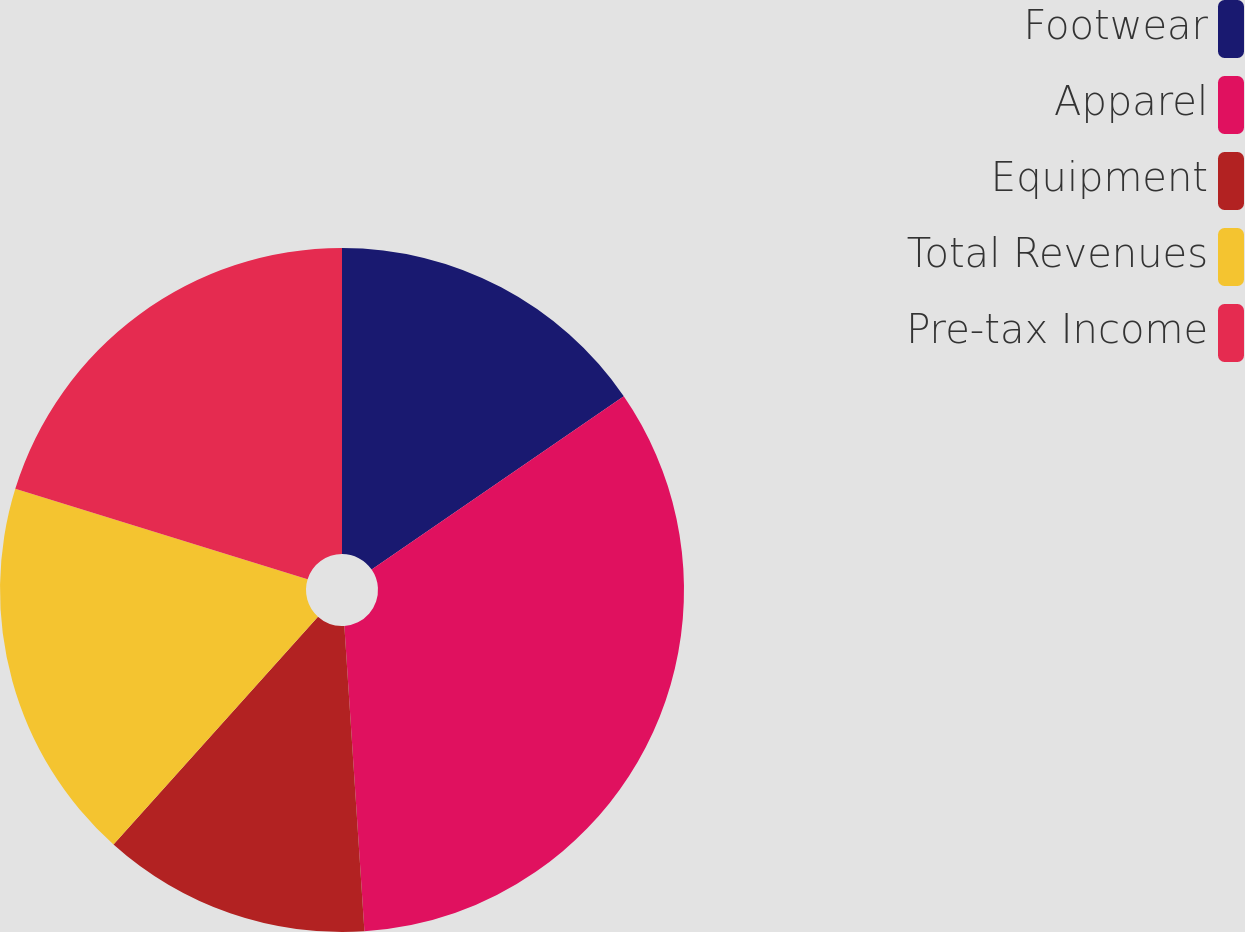Convert chart to OTSL. <chart><loc_0><loc_0><loc_500><loc_500><pie_chart><fcel>Footwear<fcel>Apparel<fcel>Equipment<fcel>Total Revenues<fcel>Pre-tax Income<nl><fcel>15.41%<fcel>33.54%<fcel>12.69%<fcel>18.13%<fcel>20.22%<nl></chart> 